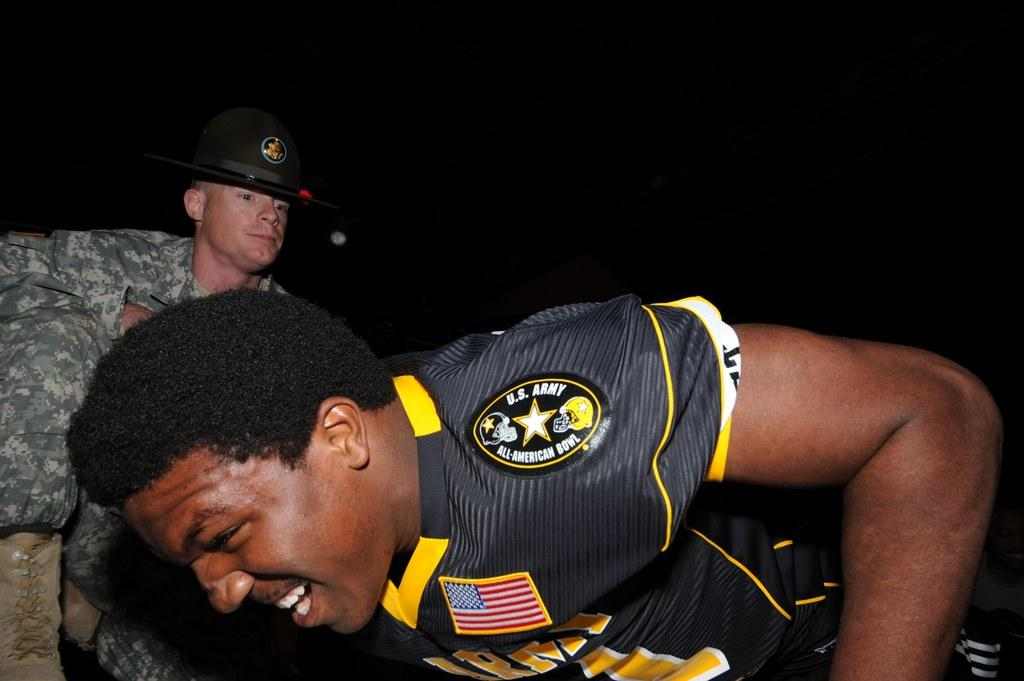How many people are in the image? There are two men in the image. What are the occupations of the men in the image? Both men are army officers. What is one of the men doing in the image? One person is doing push-ups on the floor. What is the other officer doing in the image? The other officer is sitting behind him. What can be observed about the lighting in the image? The background of the image is dark. What type of music can be heard playing in the background of the image? There is no music present in the image; it is a scene of two army officers, one doing push-ups and the other sitting behind him. 